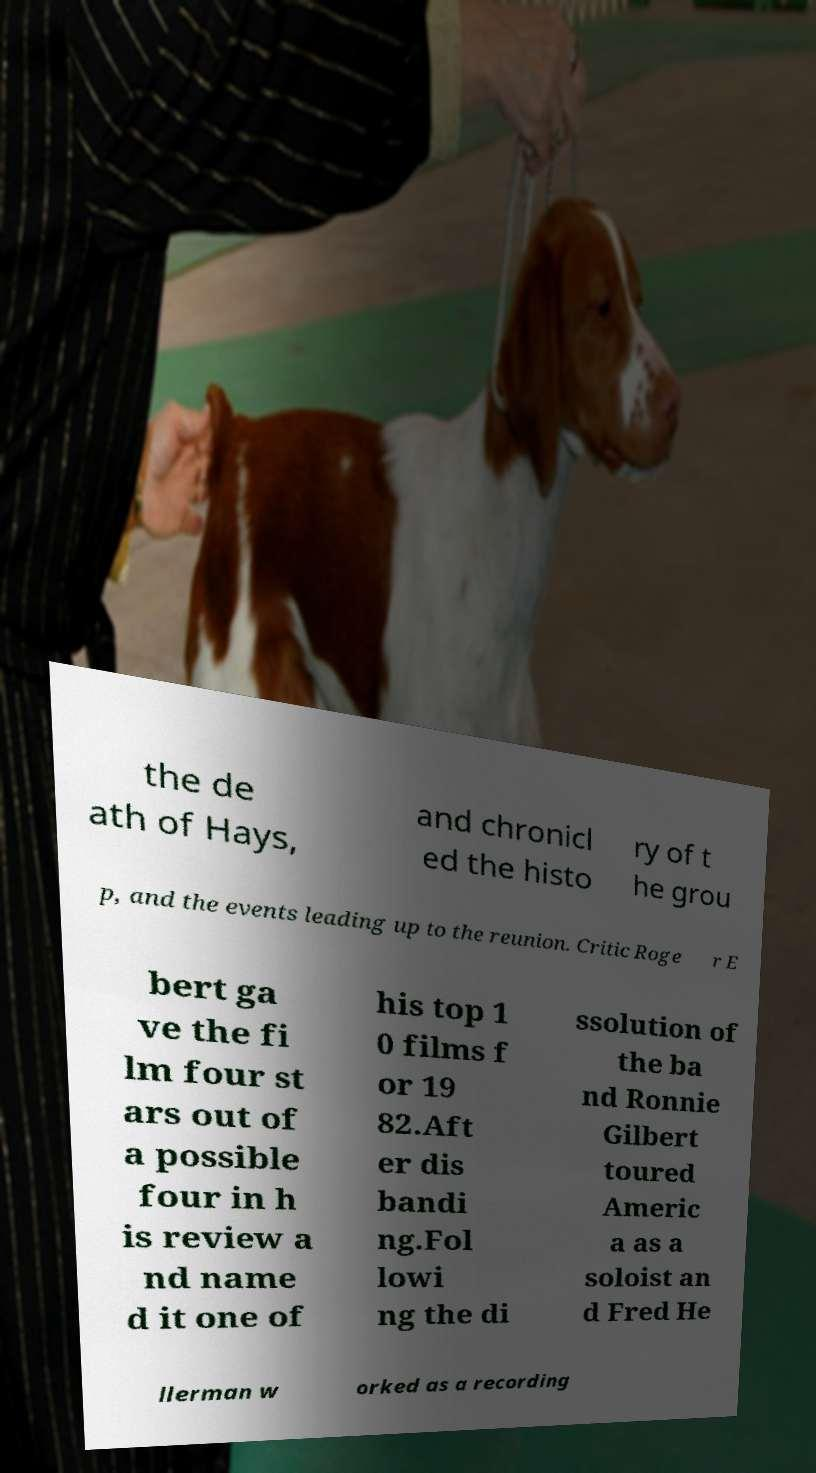Can you read and provide the text displayed in the image?This photo seems to have some interesting text. Can you extract and type it out for me? the de ath of Hays, and chronicl ed the histo ry of t he grou p, and the events leading up to the reunion. Critic Roge r E bert ga ve the fi lm four st ars out of a possible four in h is review a nd name d it one of his top 1 0 films f or 19 82.Aft er dis bandi ng.Fol lowi ng the di ssolution of the ba nd Ronnie Gilbert toured Americ a as a soloist an d Fred He llerman w orked as a recording 